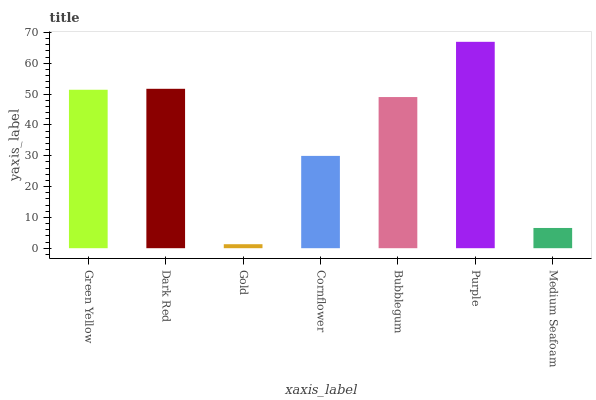Is Dark Red the minimum?
Answer yes or no. No. Is Dark Red the maximum?
Answer yes or no. No. Is Dark Red greater than Green Yellow?
Answer yes or no. Yes. Is Green Yellow less than Dark Red?
Answer yes or no. Yes. Is Green Yellow greater than Dark Red?
Answer yes or no. No. Is Dark Red less than Green Yellow?
Answer yes or no. No. Is Bubblegum the high median?
Answer yes or no. Yes. Is Bubblegum the low median?
Answer yes or no. Yes. Is Purple the high median?
Answer yes or no. No. Is Green Yellow the low median?
Answer yes or no. No. 